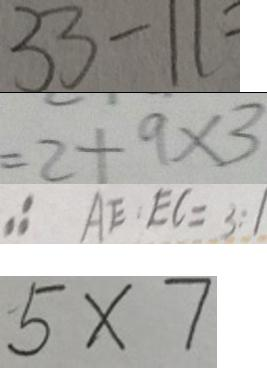<formula> <loc_0><loc_0><loc_500><loc_500>3 3 - 1 1 = 
 = 2 + 9 \times 3 
 \therefore A E : E C = 3 : 1 
 5 \times 7</formula> 